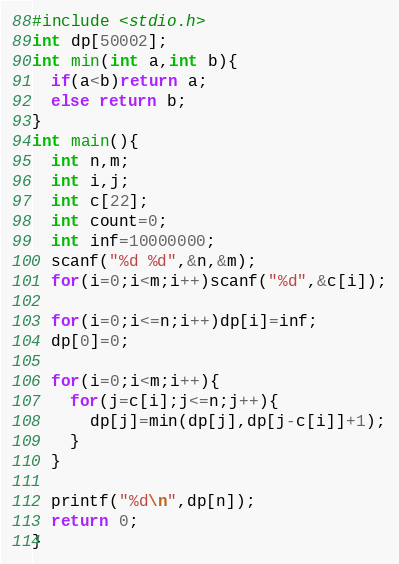Convert code to text. <code><loc_0><loc_0><loc_500><loc_500><_C_>#include <stdio.h>
int dp[50002];
int min(int a,int b){
  if(a<b)return a;
  else return b;
}
int main(){
  int n,m;
  int i,j;
  int c[22];
  int count=0;
  int inf=10000000;
  scanf("%d %d",&n,&m);
  for(i=0;i<m;i++)scanf("%d",&c[i]);

  for(i=0;i<=n;i++)dp[i]=inf;
  dp[0]=0;
  
  for(i=0;i<m;i++){
    for(j=c[i];j<=n;j++){
      dp[j]=min(dp[j],dp[j-c[i]]+1);
    }
  }
 
  printf("%d\n",dp[n]);
  return 0;
}</code> 